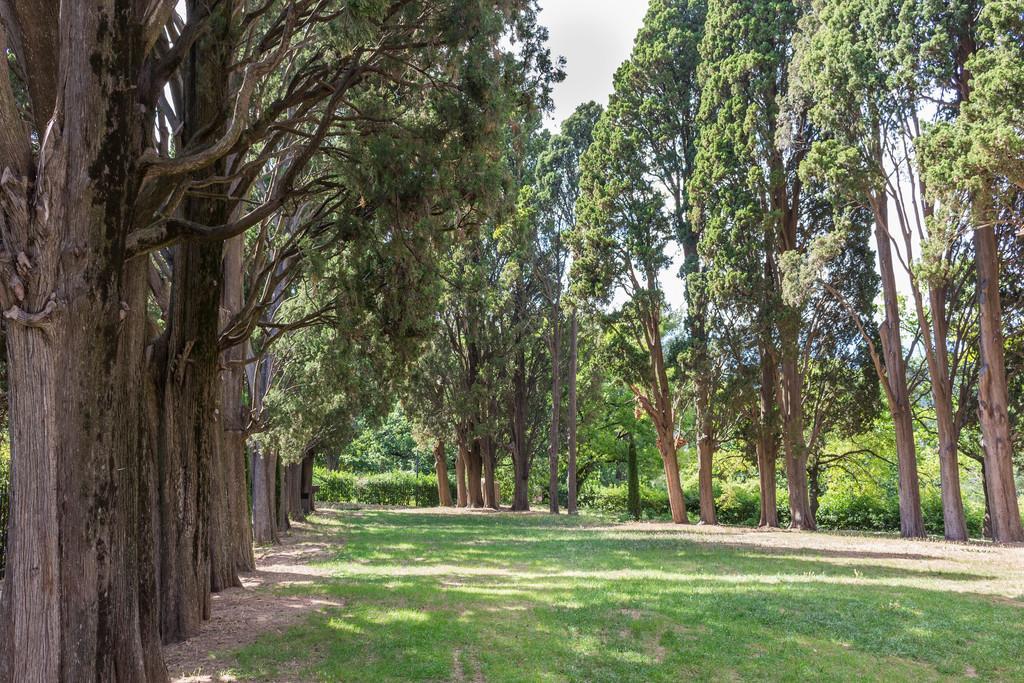Please provide a concise description of this image. In this picture I can see few trees and grass on the ground and I can see a cloudy sky. 